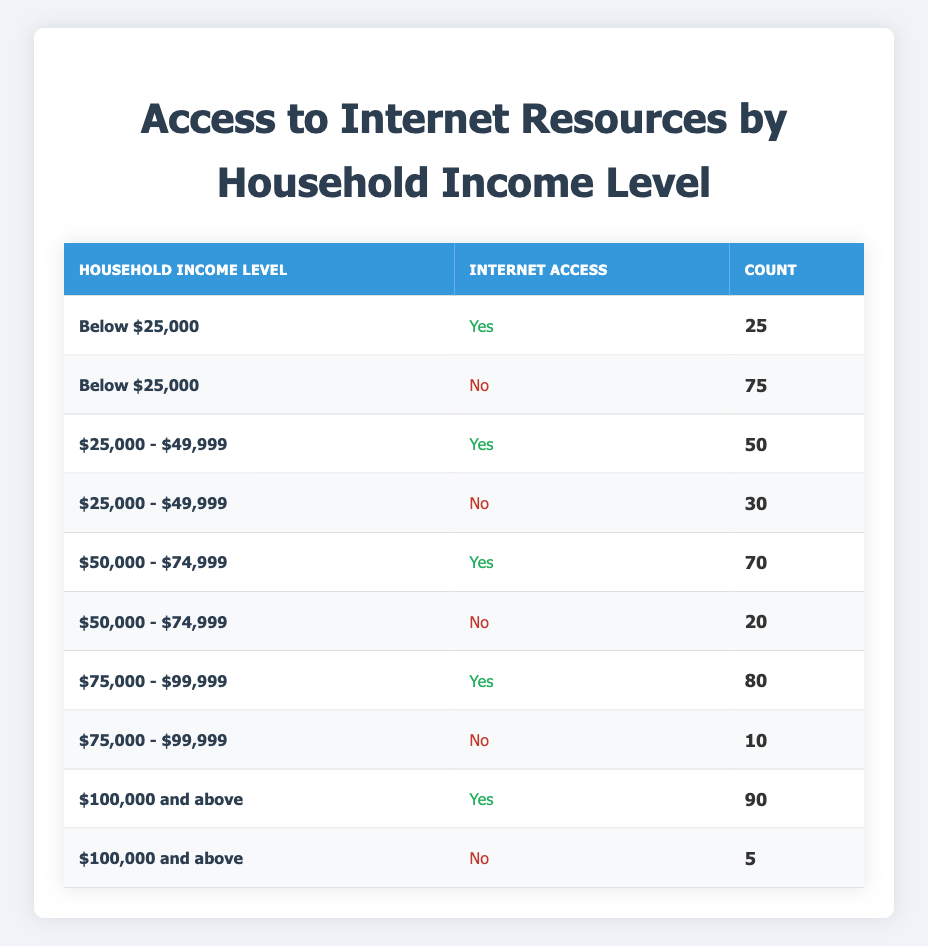What is the count of households earning below $25,000 that have internet access? From the table, we can see that for households with an income level of "Below $25,000," the count with internet access is listed as 25.
Answer: 25 How many households earning $50,000 to $74,999 do not have internet access? Looking at the "Household Income Level" of "$50,000 - $74,999," the count for those without internet access is shown as 20.
Answer: 20 What is the total number of households that have internet access across all income levels? We sum the counts of households with internet access across the income levels: 25 (below $25,000) + 50 ($25,000 - $49,999) + 70 ($50,000 - $74,999) + 80 ($75,000 - $99,999) + 90 ($100,000 and above) = 315.
Answer: 315 Is it true that the majority of households earning between $25,000 and $49,999 have internet access? To determine this, we check the counts: 50 have access, and 30 do not. Since 50 > 30, it confirms that the majority do have internet access.
Answer: Yes What is the difference in the number of households that have internet access between the $100,000 and above income level and the below $25,000 income level? The count for $100,000 and above is 90, and for below $25,000, it is 25. The difference is 90 - 25 = 65.
Answer: 65 How does the percentage of families with internet access under $50,000 compare to those with internet access above $50,000? For families below $50,000: (25 + 50) = 75 have access out of 100 total, giving 75%. For families above $50,000: (70 + 80 + 90) = 240 have access out of 300 total, giving 80%. Since 75% is less than 80%, families with internet access above $50,000 are higher.
Answer: Families above $50,000 have a higher percentage of internet access What is the total number of households without internet access in the $75,000 to $99,999 income level? The table shows that for households in the "$75,000 - $99,999" income range, the count without access is stated as 10.
Answer: 10 Is it accurate that the income level $100,000 and above has fewer households without internet access than the income level between $50,000 and $74,999? There are 5 households without access in the $100,000 and above category and 20 in the $50,000 - $74,999 category. Since 5 < 20, the assertion is correct.
Answer: Yes 